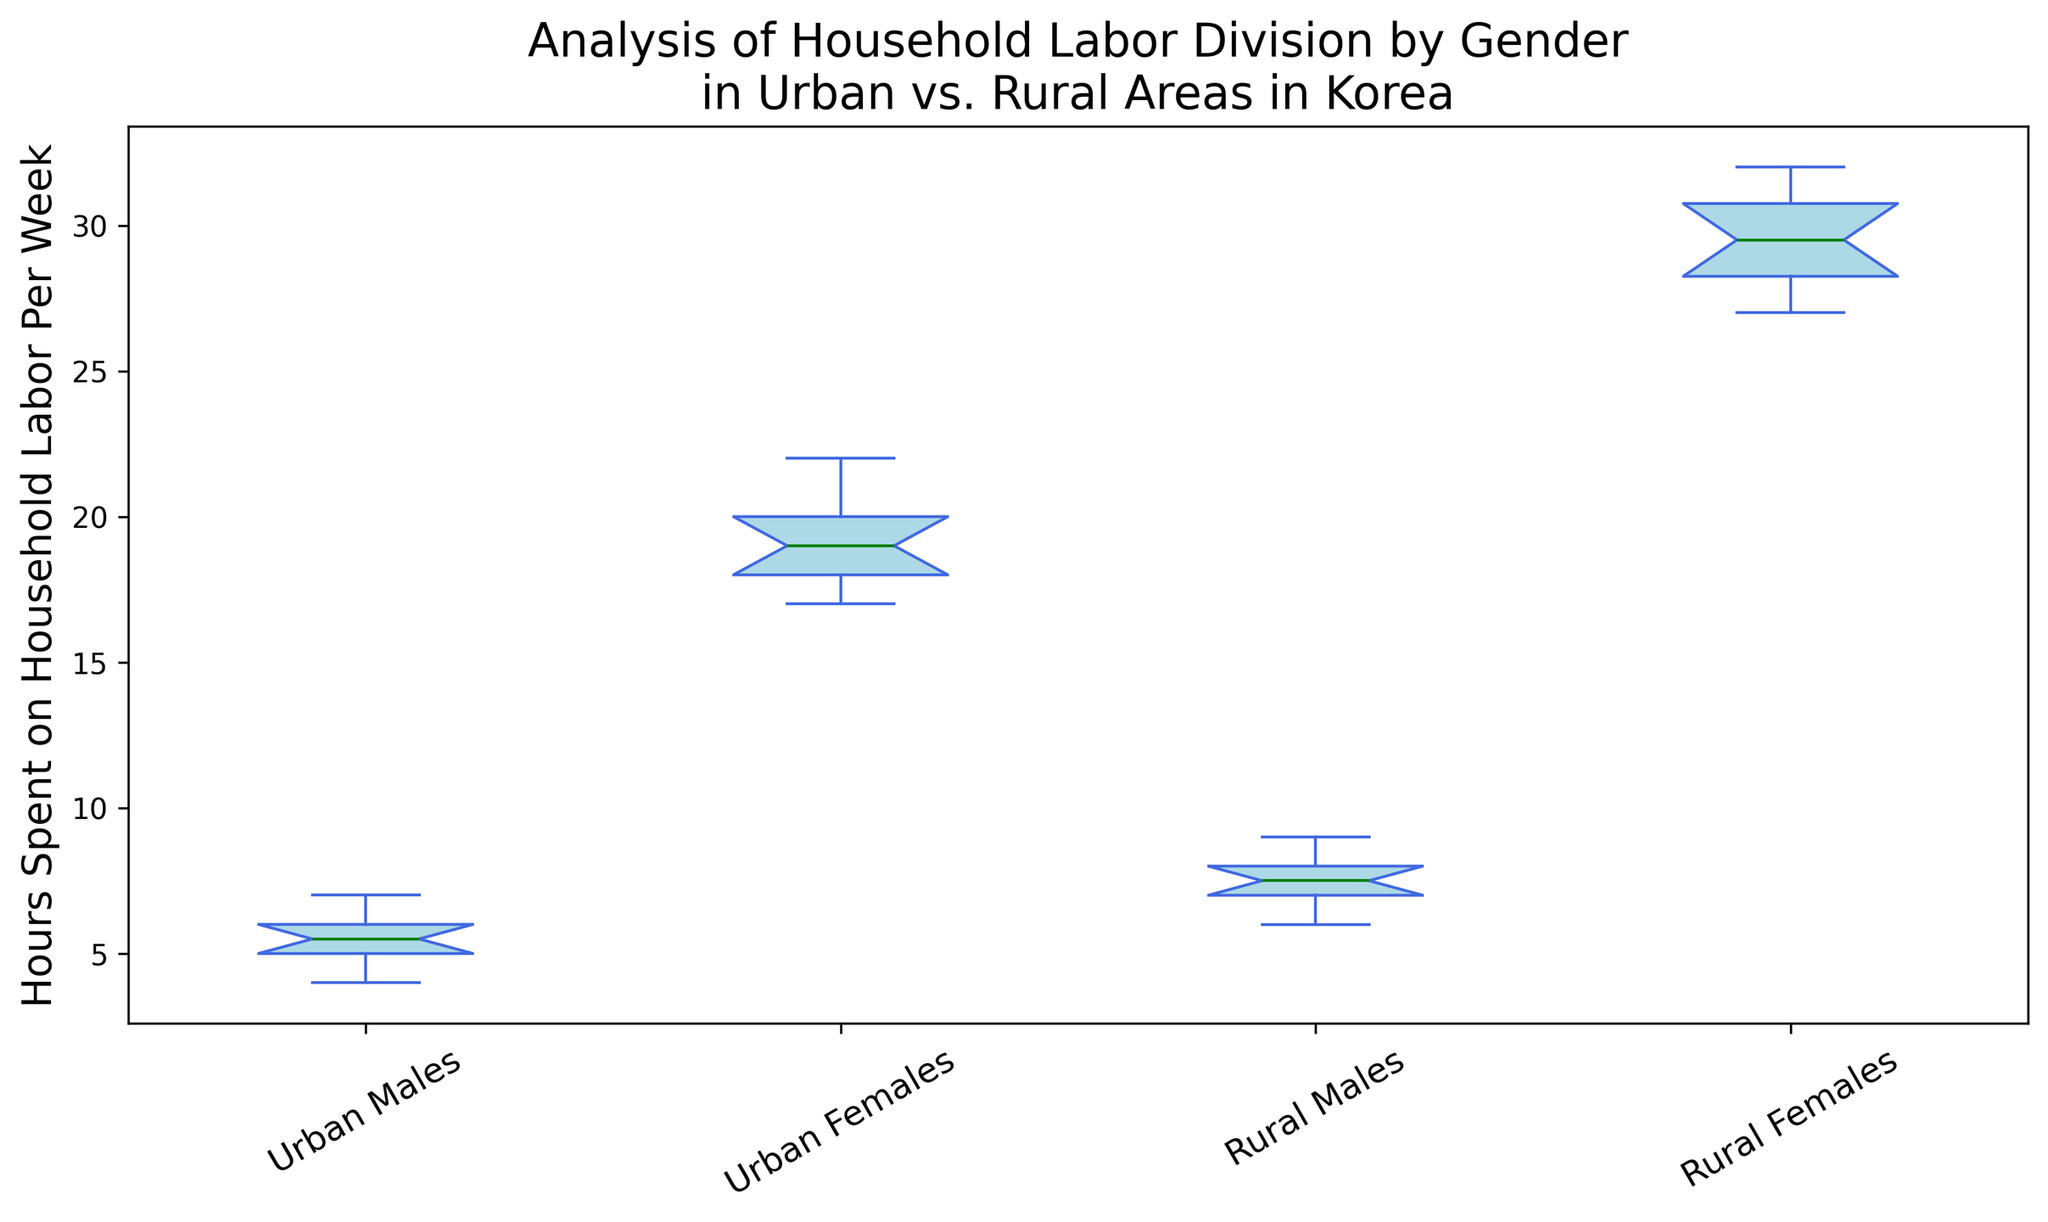What is the median value of hours spent on household labor per week for urban females? The figure's boxplot for urban females shows a green line indicating the median value. This value appears to be around 19 hours per week.
Answer: 19 Which group has the smallest range of hours spent on household labor per week? By visually comparing the whiskers' length of each group's boxplot, we see that rural males have the smallest range.
Answer: Rural males Do urban males spend more or less time on household labor per week compared to rural males? Comparing the medians, urban males have a median around 5.5 hours, while rural males have a median closer to 7.5 hours. Urban males spend less time.
Answer: Less What is the interquartile range (IQR) for rural females? The IQR is calculated as the difference between the third quartile (Q3) and the first quartile (Q1). From the boxplot, Q3 is around 30.5 hours, and Q1 is approximately 28 hours. So, the IQR is 30.5 - 28 = 2.5 hours.
Answer: 2.5 Which group has the highest median hours spent on household labor per week? Looking at the green median lines in the boxplots, rural females have the highest median, around 29.5 hours per week.
Answer: Rural females Are there any outliers in the data for urban males and urban females? Outliers are indicated as points outside the whiskers. For urban males, there are no outliers. For urban females, there are no outliers either.
Answer: No Which group shows the most variability in hours spent on household labor per week? Variability is suggested by the range and spread of the box and whiskers. Rural females have the widest spread, indicating the most variability.
Answer: Rural females Compare the median values of hours spent on household labor per week by urban females and rural males. The median value for urban females is around 19 hours per week, and for rural males, it is around 7.5 hours per week. Urban females have a higher median.
Answer: Urban females What is the approximate upper whisker value for urban males on the boxplot? The upper whisker extends to the maximum non-outlier value. For urban males, this appears to be around 7 hours per week.
Answer: 7 